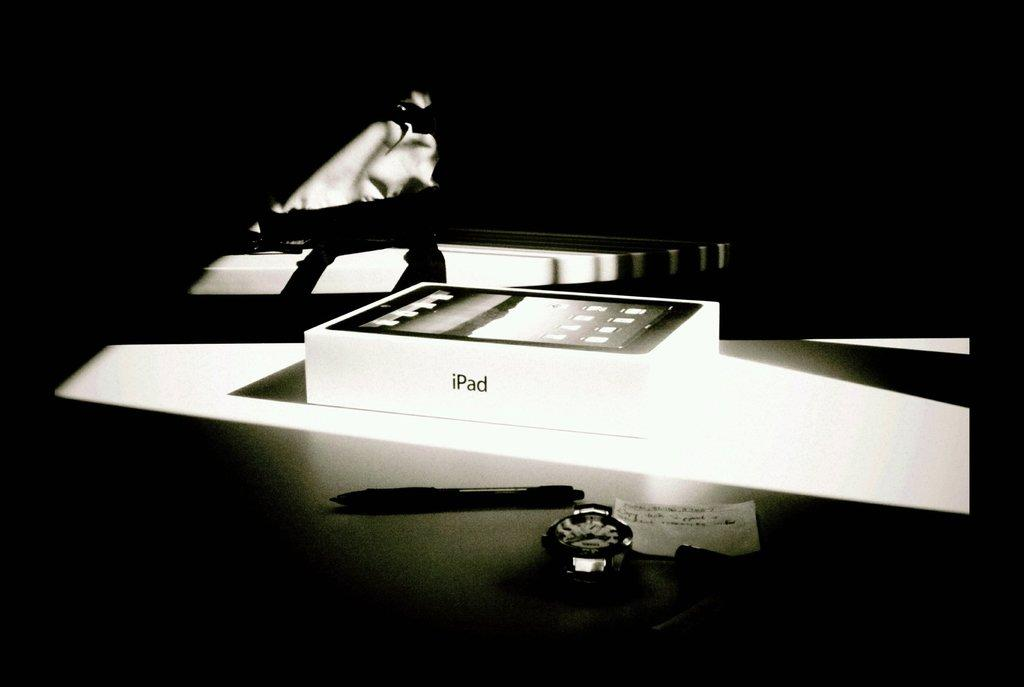Provide a one-sentence caption for the provided image. A black and white photo of a white box that reads iPad. 